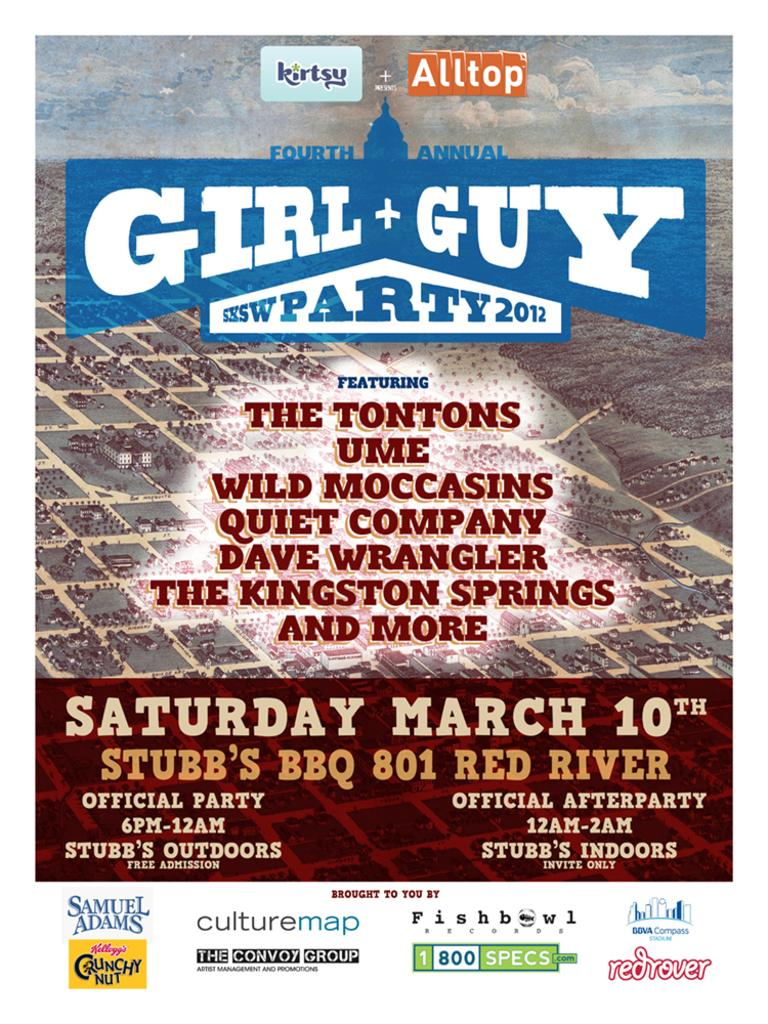<image>
Provide a brief description of the given image. A Girl + Guy Party is advertised for Saturday March 10th at Stubb's BBQ. 